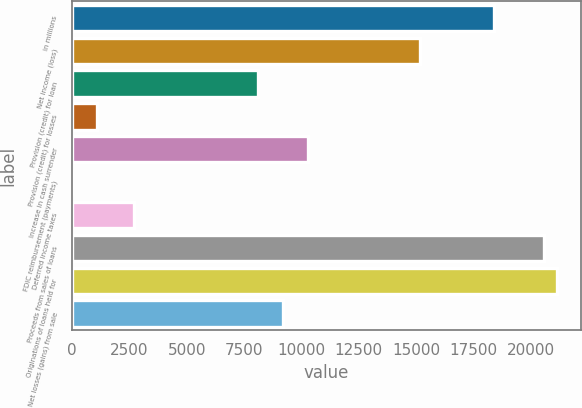<chart> <loc_0><loc_0><loc_500><loc_500><bar_chart><fcel>in millions<fcel>Net income (loss)<fcel>Provision (credit) for loan<fcel>Provision (credit) for losses<fcel>Increase in cash surrender<fcel>FDIC reimbursement (payments)<fcel>Deferred income taxes<fcel>Proceeds from sales of loans<fcel>Originations of loans held for<fcel>Net losses (gains) from sale<nl><fcel>18408.6<fcel>15160.2<fcel>8122<fcel>1083.8<fcel>10287.6<fcel>1<fcel>2708<fcel>20574.2<fcel>21115.6<fcel>9204.8<nl></chart> 